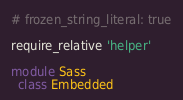Convert code to text. <code><loc_0><loc_0><loc_500><loc_500><_Ruby_># frozen_string_literal: true

require_relative 'helper'

module Sass
  class Embedded</code> 